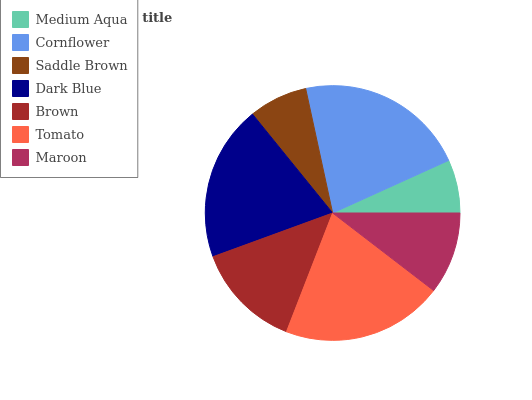Is Medium Aqua the minimum?
Answer yes or no. Yes. Is Cornflower the maximum?
Answer yes or no. Yes. Is Saddle Brown the minimum?
Answer yes or no. No. Is Saddle Brown the maximum?
Answer yes or no. No. Is Cornflower greater than Saddle Brown?
Answer yes or no. Yes. Is Saddle Brown less than Cornflower?
Answer yes or no. Yes. Is Saddle Brown greater than Cornflower?
Answer yes or no. No. Is Cornflower less than Saddle Brown?
Answer yes or no. No. Is Brown the high median?
Answer yes or no. Yes. Is Brown the low median?
Answer yes or no. Yes. Is Dark Blue the high median?
Answer yes or no. No. Is Cornflower the low median?
Answer yes or no. No. 